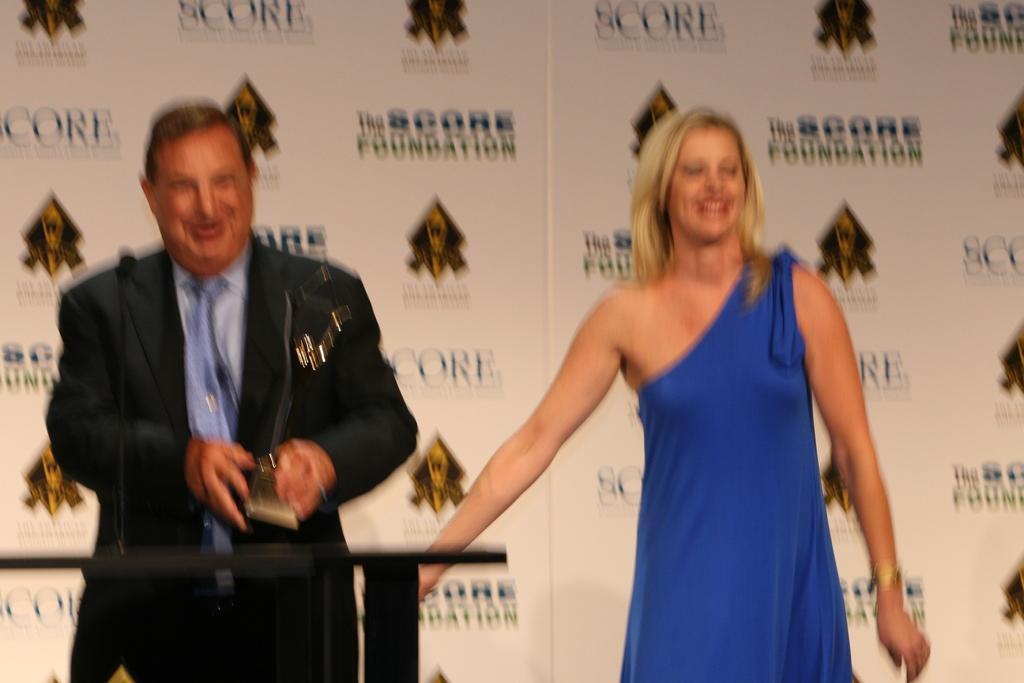Please provide a concise description of this image. This is a blur image. Here I can see a woman and a man are standing and smiling. The man is holding an award in the hands. At the back of him there is a table. In the background there is a board on which I can see the text. 